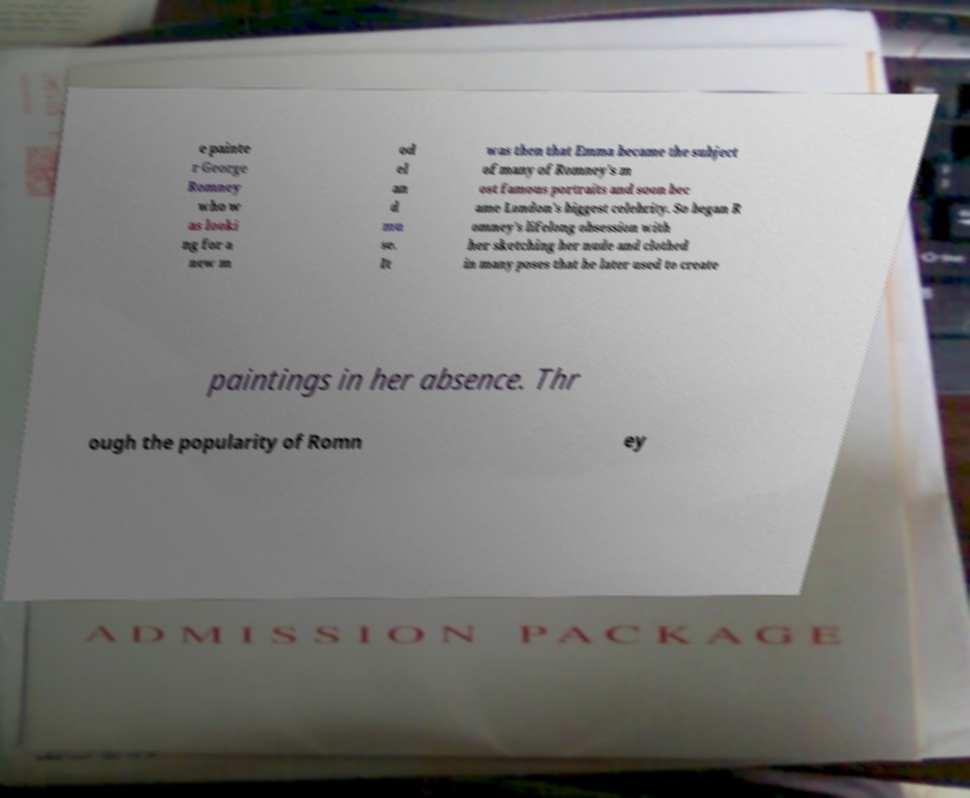Can you read and provide the text displayed in the image?This photo seems to have some interesting text. Can you extract and type it out for me? e painte r George Romney who w as looki ng for a new m od el an d mu se. It was then that Emma became the subject of many of Romney's m ost famous portraits and soon bec ame London's biggest celebrity. So began R omney's lifelong obsession with her sketching her nude and clothed in many poses that he later used to create paintings in her absence. Thr ough the popularity of Romn ey 